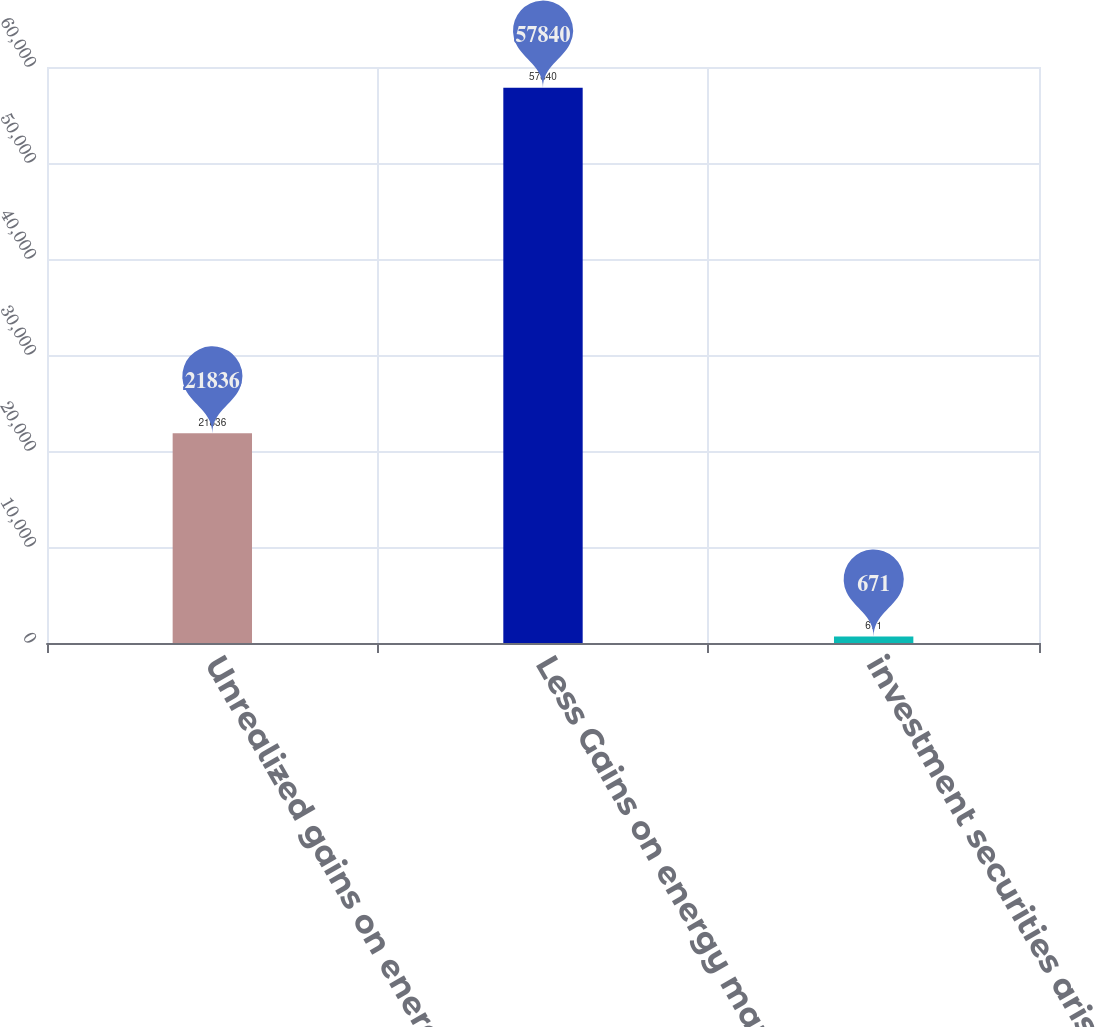Convert chart to OTSL. <chart><loc_0><loc_0><loc_500><loc_500><bar_chart><fcel>Unrealized gains on energy<fcel>Less Gains on energy marketing<fcel>investment securities arising<nl><fcel>21836<fcel>57840<fcel>671<nl></chart> 